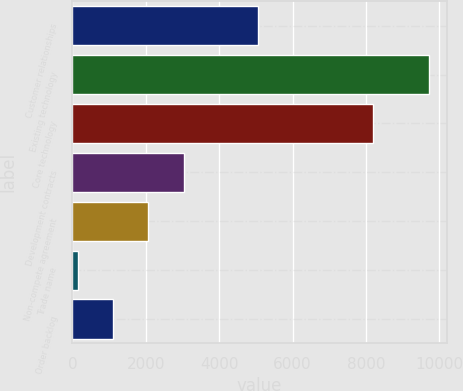Convert chart to OTSL. <chart><loc_0><loc_0><loc_500><loc_500><bar_chart><fcel>Customer relationships<fcel>Existing technology<fcel>Core technology<fcel>Development contracts<fcel>Non-compete agreement<fcel>Trade name<fcel>Order backlog<nl><fcel>5050<fcel>9720<fcel>8200<fcel>3028<fcel>2072<fcel>160<fcel>1116<nl></chart> 